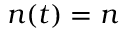<formula> <loc_0><loc_0><loc_500><loc_500>n ( t ) = n</formula> 